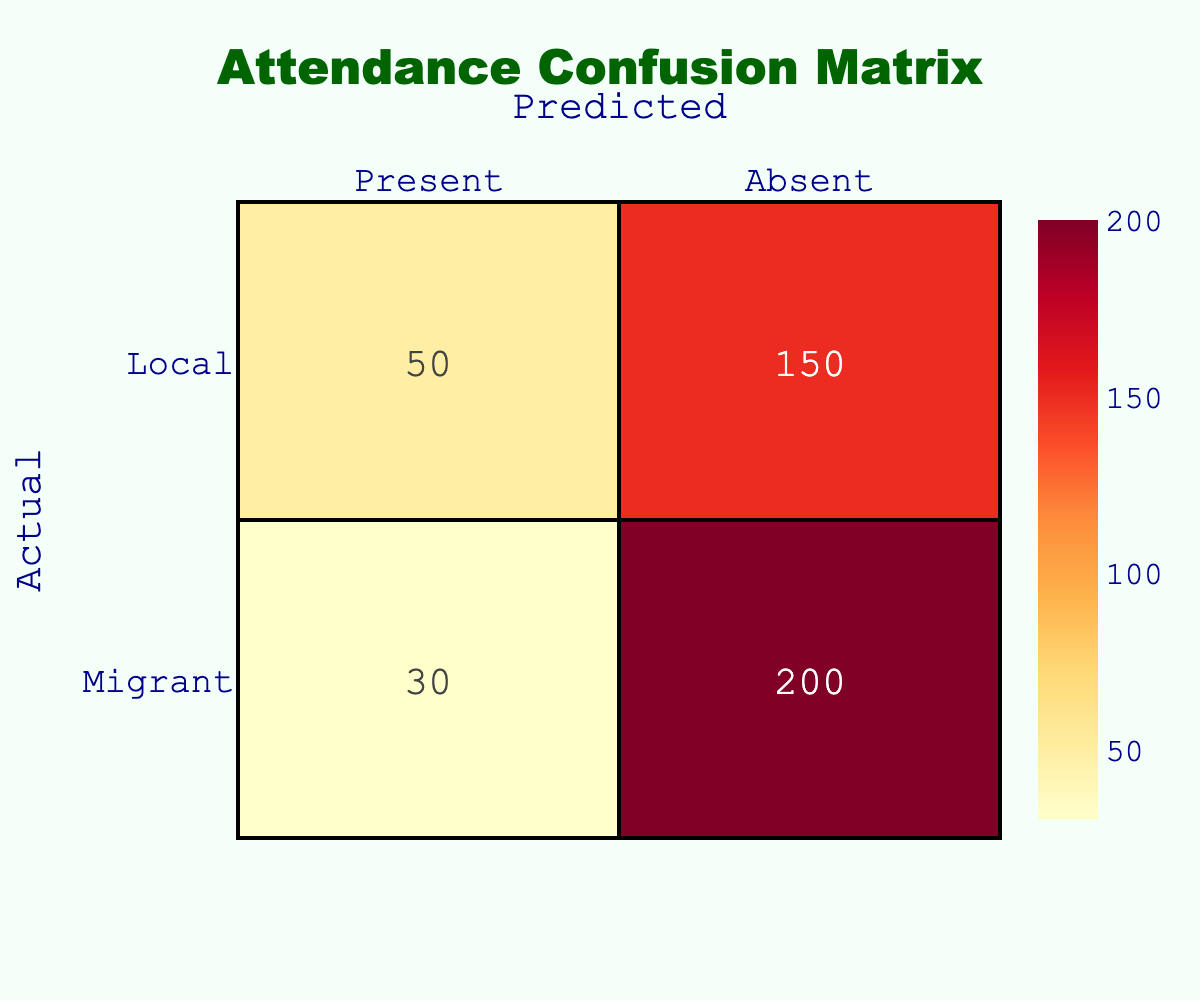What is the number of migrant students who were present? According to the table, under the row for "Migrant" and the column for "Present," the count is 150.
Answer: 150 What is the total number of local students? To find the total number of local students, we sum the counts for both the "Present" and "Absent" categories: 200 (Present) + 30 (Absent) = 230.
Answer: 230 Are there more migrant students present than local students? To verify this, we compare the counts: 150 (Migrant Present) versus 200 (Local Present). Since 150 is less than 200, the answer is no.
Answer: No What is the difference in attendance between migrant and local students who were absent? From the table, migrant students absent are 50 and local students absent are 30. The difference is 50 (Migrant Absent) - 30 (Local Absent) = 20.
Answer: 20 What is the attendance rate for local students compared to migrant students? First, we determine the total attendance for both: For locals, 200 (Present) plus 30 (Absent) equals 230, and for migrants, 150 (Present) plus 50 (Absent) equals 200. The attendance rates are thus local: 200/230, migrant: 150/200. Comparing these, locals have a higher rate.
Answer: Local students have a higher attendance rate How many students in total were present? To find the total present, we add the number of migrant and local students who were present: 150 (Migrant Present) + 200 (Local Present) = 350.
Answer: 350 Is the total number of absent students higher than the total number of present students? The total absent students are calculated as 50 (Migrant Absent) + 30 (Local Absent) = 80. Since the total present students are 350, we find that 80 is less than 350, making the answer no.
Answer: No What percentage of migrant students were present? Total migrant students are 150 present plus 50 absent, so 200 in total. The percentage of present students is then (150/200) * 100, which equals 75%.
Answer: 75% What is the ratio of present to absent students for local students? The count of local students present is 200 and absent is 30. The ratio is therefore 200:30, which simplifies down to approximately 6.67:1.
Answer: 6.67 to 1 How many more local students are present compared to absent? For local students, 200 are present and 30 are absent. The difference is 200 (Present) - 30 (Absent) = 170.
Answer: 170 